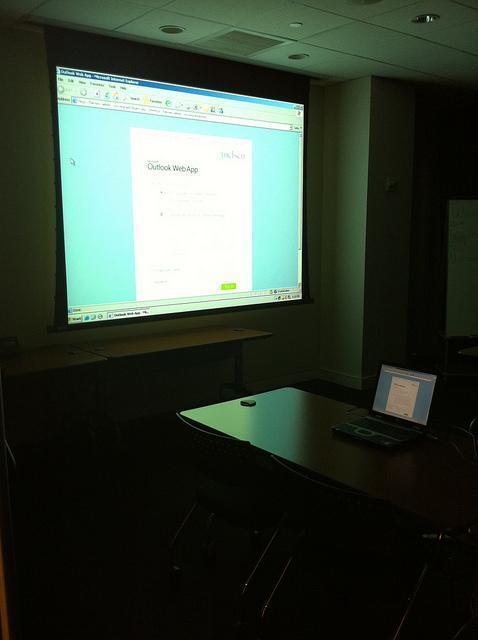How many tvs can be seen?
Give a very brief answer. 2. How many laptops are in the picture?
Give a very brief answer. 2. 